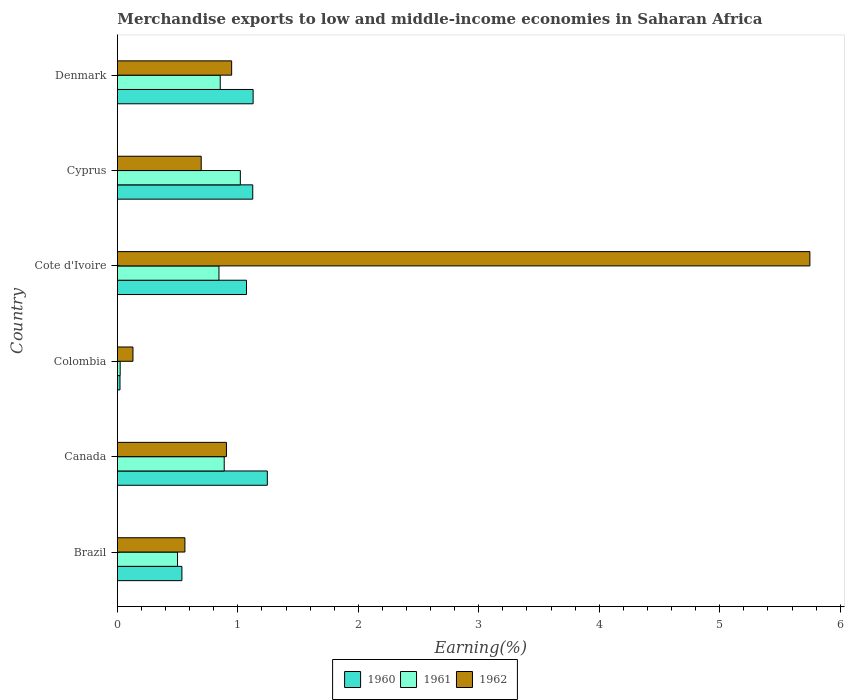How many groups of bars are there?
Your answer should be compact. 6. Are the number of bars on each tick of the Y-axis equal?
Ensure brevity in your answer.  Yes. How many bars are there on the 6th tick from the bottom?
Offer a very short reply. 3. What is the label of the 3rd group of bars from the top?
Your response must be concise. Cote d'Ivoire. In how many cases, is the number of bars for a given country not equal to the number of legend labels?
Make the answer very short. 0. What is the percentage of amount earned from merchandise exports in 1961 in Canada?
Ensure brevity in your answer.  0.89. Across all countries, what is the maximum percentage of amount earned from merchandise exports in 1962?
Your answer should be very brief. 5.75. Across all countries, what is the minimum percentage of amount earned from merchandise exports in 1961?
Your answer should be very brief. 0.02. In which country was the percentage of amount earned from merchandise exports in 1962 maximum?
Ensure brevity in your answer.  Cote d'Ivoire. What is the total percentage of amount earned from merchandise exports in 1962 in the graph?
Offer a terse response. 8.99. What is the difference between the percentage of amount earned from merchandise exports in 1961 in Colombia and that in Cyprus?
Give a very brief answer. -1. What is the difference between the percentage of amount earned from merchandise exports in 1960 in Canada and the percentage of amount earned from merchandise exports in 1961 in Colombia?
Provide a succinct answer. 1.22. What is the average percentage of amount earned from merchandise exports in 1961 per country?
Your answer should be compact. 0.69. What is the difference between the percentage of amount earned from merchandise exports in 1961 and percentage of amount earned from merchandise exports in 1962 in Brazil?
Make the answer very short. -0.06. In how many countries, is the percentage of amount earned from merchandise exports in 1962 greater than 5.2 %?
Your answer should be very brief. 1. What is the ratio of the percentage of amount earned from merchandise exports in 1962 in Brazil to that in Colombia?
Your answer should be compact. 4.34. Is the percentage of amount earned from merchandise exports in 1962 in Colombia less than that in Denmark?
Provide a succinct answer. Yes. What is the difference between the highest and the second highest percentage of amount earned from merchandise exports in 1960?
Offer a very short reply. 0.12. What is the difference between the highest and the lowest percentage of amount earned from merchandise exports in 1960?
Provide a short and direct response. 1.22. Is the sum of the percentage of amount earned from merchandise exports in 1960 in Cote d'Ivoire and Denmark greater than the maximum percentage of amount earned from merchandise exports in 1962 across all countries?
Offer a very short reply. No. What does the 3rd bar from the top in Cyprus represents?
Provide a short and direct response. 1960. Is it the case that in every country, the sum of the percentage of amount earned from merchandise exports in 1962 and percentage of amount earned from merchandise exports in 1960 is greater than the percentage of amount earned from merchandise exports in 1961?
Keep it short and to the point. Yes. Are all the bars in the graph horizontal?
Your answer should be compact. Yes. What is the difference between two consecutive major ticks on the X-axis?
Make the answer very short. 1. Does the graph contain any zero values?
Provide a short and direct response. No. Does the graph contain grids?
Your response must be concise. No. Where does the legend appear in the graph?
Make the answer very short. Bottom center. How many legend labels are there?
Offer a very short reply. 3. What is the title of the graph?
Keep it short and to the point. Merchandise exports to low and middle-income economies in Saharan Africa. Does "1964" appear as one of the legend labels in the graph?
Ensure brevity in your answer.  No. What is the label or title of the X-axis?
Provide a succinct answer. Earning(%). What is the Earning(%) of 1960 in Brazil?
Ensure brevity in your answer.  0.54. What is the Earning(%) of 1961 in Brazil?
Give a very brief answer. 0.5. What is the Earning(%) of 1962 in Brazil?
Offer a terse response. 0.56. What is the Earning(%) in 1960 in Canada?
Provide a short and direct response. 1.24. What is the Earning(%) of 1961 in Canada?
Your response must be concise. 0.89. What is the Earning(%) of 1962 in Canada?
Provide a succinct answer. 0.9. What is the Earning(%) in 1960 in Colombia?
Your response must be concise. 0.02. What is the Earning(%) of 1961 in Colombia?
Offer a terse response. 0.02. What is the Earning(%) of 1962 in Colombia?
Your answer should be very brief. 0.13. What is the Earning(%) in 1960 in Cote d'Ivoire?
Provide a short and direct response. 1.07. What is the Earning(%) in 1961 in Cote d'Ivoire?
Give a very brief answer. 0.84. What is the Earning(%) of 1962 in Cote d'Ivoire?
Make the answer very short. 5.75. What is the Earning(%) of 1960 in Cyprus?
Offer a terse response. 1.12. What is the Earning(%) in 1961 in Cyprus?
Your answer should be very brief. 1.02. What is the Earning(%) in 1962 in Cyprus?
Provide a succinct answer. 0.7. What is the Earning(%) of 1960 in Denmark?
Your answer should be compact. 1.13. What is the Earning(%) of 1961 in Denmark?
Your response must be concise. 0.85. What is the Earning(%) in 1962 in Denmark?
Offer a terse response. 0.95. Across all countries, what is the maximum Earning(%) in 1960?
Give a very brief answer. 1.24. Across all countries, what is the maximum Earning(%) of 1961?
Offer a terse response. 1.02. Across all countries, what is the maximum Earning(%) of 1962?
Your answer should be compact. 5.75. Across all countries, what is the minimum Earning(%) in 1960?
Your answer should be very brief. 0.02. Across all countries, what is the minimum Earning(%) in 1961?
Offer a very short reply. 0.02. Across all countries, what is the minimum Earning(%) in 1962?
Your answer should be very brief. 0.13. What is the total Earning(%) in 1960 in the graph?
Make the answer very short. 5.12. What is the total Earning(%) in 1961 in the graph?
Your answer should be very brief. 4.13. What is the total Earning(%) in 1962 in the graph?
Your answer should be very brief. 8.99. What is the difference between the Earning(%) in 1960 in Brazil and that in Canada?
Offer a terse response. -0.71. What is the difference between the Earning(%) of 1961 in Brazil and that in Canada?
Give a very brief answer. -0.39. What is the difference between the Earning(%) in 1962 in Brazil and that in Canada?
Offer a terse response. -0.34. What is the difference between the Earning(%) in 1960 in Brazil and that in Colombia?
Offer a terse response. 0.51. What is the difference between the Earning(%) in 1961 in Brazil and that in Colombia?
Your answer should be compact. 0.48. What is the difference between the Earning(%) in 1962 in Brazil and that in Colombia?
Offer a very short reply. 0.43. What is the difference between the Earning(%) in 1960 in Brazil and that in Cote d'Ivoire?
Ensure brevity in your answer.  -0.54. What is the difference between the Earning(%) in 1961 in Brazil and that in Cote d'Ivoire?
Give a very brief answer. -0.34. What is the difference between the Earning(%) in 1962 in Brazil and that in Cote d'Ivoire?
Your answer should be compact. -5.19. What is the difference between the Earning(%) in 1960 in Brazil and that in Cyprus?
Give a very brief answer. -0.59. What is the difference between the Earning(%) of 1961 in Brazil and that in Cyprus?
Make the answer very short. -0.52. What is the difference between the Earning(%) in 1962 in Brazil and that in Cyprus?
Offer a very short reply. -0.14. What is the difference between the Earning(%) of 1960 in Brazil and that in Denmark?
Keep it short and to the point. -0.59. What is the difference between the Earning(%) in 1961 in Brazil and that in Denmark?
Ensure brevity in your answer.  -0.35. What is the difference between the Earning(%) of 1962 in Brazil and that in Denmark?
Offer a terse response. -0.39. What is the difference between the Earning(%) in 1960 in Canada and that in Colombia?
Your answer should be very brief. 1.22. What is the difference between the Earning(%) in 1961 in Canada and that in Colombia?
Provide a short and direct response. 0.86. What is the difference between the Earning(%) of 1962 in Canada and that in Colombia?
Offer a very short reply. 0.78. What is the difference between the Earning(%) of 1960 in Canada and that in Cote d'Ivoire?
Offer a very short reply. 0.17. What is the difference between the Earning(%) of 1961 in Canada and that in Cote d'Ivoire?
Keep it short and to the point. 0.04. What is the difference between the Earning(%) in 1962 in Canada and that in Cote d'Ivoire?
Provide a succinct answer. -4.84. What is the difference between the Earning(%) of 1960 in Canada and that in Cyprus?
Make the answer very short. 0.12. What is the difference between the Earning(%) in 1961 in Canada and that in Cyprus?
Offer a terse response. -0.13. What is the difference between the Earning(%) in 1962 in Canada and that in Cyprus?
Provide a succinct answer. 0.21. What is the difference between the Earning(%) of 1960 in Canada and that in Denmark?
Provide a short and direct response. 0.12. What is the difference between the Earning(%) of 1961 in Canada and that in Denmark?
Offer a terse response. 0.03. What is the difference between the Earning(%) in 1962 in Canada and that in Denmark?
Offer a very short reply. -0.04. What is the difference between the Earning(%) in 1960 in Colombia and that in Cote d'Ivoire?
Your answer should be very brief. -1.05. What is the difference between the Earning(%) in 1961 in Colombia and that in Cote d'Ivoire?
Offer a terse response. -0.82. What is the difference between the Earning(%) in 1962 in Colombia and that in Cote d'Ivoire?
Keep it short and to the point. -5.62. What is the difference between the Earning(%) in 1960 in Colombia and that in Cyprus?
Provide a succinct answer. -1.1. What is the difference between the Earning(%) in 1961 in Colombia and that in Cyprus?
Keep it short and to the point. -1. What is the difference between the Earning(%) in 1962 in Colombia and that in Cyprus?
Give a very brief answer. -0.57. What is the difference between the Earning(%) of 1960 in Colombia and that in Denmark?
Keep it short and to the point. -1.11. What is the difference between the Earning(%) in 1961 in Colombia and that in Denmark?
Offer a very short reply. -0.83. What is the difference between the Earning(%) of 1962 in Colombia and that in Denmark?
Give a very brief answer. -0.82. What is the difference between the Earning(%) in 1960 in Cote d'Ivoire and that in Cyprus?
Offer a terse response. -0.05. What is the difference between the Earning(%) in 1961 in Cote d'Ivoire and that in Cyprus?
Keep it short and to the point. -0.18. What is the difference between the Earning(%) of 1962 in Cote d'Ivoire and that in Cyprus?
Ensure brevity in your answer.  5.05. What is the difference between the Earning(%) in 1960 in Cote d'Ivoire and that in Denmark?
Provide a succinct answer. -0.06. What is the difference between the Earning(%) of 1961 in Cote d'Ivoire and that in Denmark?
Your answer should be compact. -0.01. What is the difference between the Earning(%) in 1962 in Cote d'Ivoire and that in Denmark?
Your answer should be very brief. 4.8. What is the difference between the Earning(%) in 1960 in Cyprus and that in Denmark?
Provide a succinct answer. -0. What is the difference between the Earning(%) of 1961 in Cyprus and that in Denmark?
Offer a very short reply. 0.17. What is the difference between the Earning(%) of 1962 in Cyprus and that in Denmark?
Offer a terse response. -0.25. What is the difference between the Earning(%) of 1960 in Brazil and the Earning(%) of 1961 in Canada?
Your answer should be compact. -0.35. What is the difference between the Earning(%) of 1960 in Brazil and the Earning(%) of 1962 in Canada?
Your response must be concise. -0.37. What is the difference between the Earning(%) of 1961 in Brazil and the Earning(%) of 1962 in Canada?
Give a very brief answer. -0.41. What is the difference between the Earning(%) in 1960 in Brazil and the Earning(%) in 1961 in Colombia?
Provide a short and direct response. 0.51. What is the difference between the Earning(%) of 1960 in Brazil and the Earning(%) of 1962 in Colombia?
Offer a very short reply. 0.41. What is the difference between the Earning(%) in 1961 in Brazil and the Earning(%) in 1962 in Colombia?
Your answer should be very brief. 0.37. What is the difference between the Earning(%) of 1960 in Brazil and the Earning(%) of 1961 in Cote d'Ivoire?
Ensure brevity in your answer.  -0.31. What is the difference between the Earning(%) of 1960 in Brazil and the Earning(%) of 1962 in Cote d'Ivoire?
Ensure brevity in your answer.  -5.21. What is the difference between the Earning(%) in 1961 in Brazil and the Earning(%) in 1962 in Cote d'Ivoire?
Ensure brevity in your answer.  -5.25. What is the difference between the Earning(%) in 1960 in Brazil and the Earning(%) in 1961 in Cyprus?
Offer a very short reply. -0.48. What is the difference between the Earning(%) of 1960 in Brazil and the Earning(%) of 1962 in Cyprus?
Provide a succinct answer. -0.16. What is the difference between the Earning(%) in 1961 in Brazil and the Earning(%) in 1962 in Cyprus?
Give a very brief answer. -0.2. What is the difference between the Earning(%) of 1960 in Brazil and the Earning(%) of 1961 in Denmark?
Offer a very short reply. -0.32. What is the difference between the Earning(%) of 1960 in Brazil and the Earning(%) of 1962 in Denmark?
Offer a terse response. -0.41. What is the difference between the Earning(%) in 1961 in Brazil and the Earning(%) in 1962 in Denmark?
Provide a short and direct response. -0.45. What is the difference between the Earning(%) of 1960 in Canada and the Earning(%) of 1961 in Colombia?
Make the answer very short. 1.22. What is the difference between the Earning(%) in 1960 in Canada and the Earning(%) in 1962 in Colombia?
Provide a short and direct response. 1.12. What is the difference between the Earning(%) in 1961 in Canada and the Earning(%) in 1962 in Colombia?
Make the answer very short. 0.76. What is the difference between the Earning(%) of 1960 in Canada and the Earning(%) of 1961 in Cote d'Ivoire?
Your answer should be compact. 0.4. What is the difference between the Earning(%) of 1960 in Canada and the Earning(%) of 1962 in Cote d'Ivoire?
Your answer should be very brief. -4.5. What is the difference between the Earning(%) in 1961 in Canada and the Earning(%) in 1962 in Cote d'Ivoire?
Your answer should be very brief. -4.86. What is the difference between the Earning(%) of 1960 in Canada and the Earning(%) of 1961 in Cyprus?
Provide a succinct answer. 0.22. What is the difference between the Earning(%) of 1960 in Canada and the Earning(%) of 1962 in Cyprus?
Your answer should be compact. 0.55. What is the difference between the Earning(%) in 1961 in Canada and the Earning(%) in 1962 in Cyprus?
Your answer should be very brief. 0.19. What is the difference between the Earning(%) in 1960 in Canada and the Earning(%) in 1961 in Denmark?
Make the answer very short. 0.39. What is the difference between the Earning(%) of 1960 in Canada and the Earning(%) of 1962 in Denmark?
Offer a very short reply. 0.3. What is the difference between the Earning(%) in 1961 in Canada and the Earning(%) in 1962 in Denmark?
Keep it short and to the point. -0.06. What is the difference between the Earning(%) of 1960 in Colombia and the Earning(%) of 1961 in Cote d'Ivoire?
Offer a terse response. -0.82. What is the difference between the Earning(%) of 1960 in Colombia and the Earning(%) of 1962 in Cote d'Ivoire?
Keep it short and to the point. -5.73. What is the difference between the Earning(%) in 1961 in Colombia and the Earning(%) in 1962 in Cote d'Ivoire?
Ensure brevity in your answer.  -5.73. What is the difference between the Earning(%) in 1960 in Colombia and the Earning(%) in 1961 in Cyprus?
Make the answer very short. -1. What is the difference between the Earning(%) in 1960 in Colombia and the Earning(%) in 1962 in Cyprus?
Keep it short and to the point. -0.67. What is the difference between the Earning(%) of 1961 in Colombia and the Earning(%) of 1962 in Cyprus?
Provide a short and direct response. -0.67. What is the difference between the Earning(%) in 1960 in Colombia and the Earning(%) in 1961 in Denmark?
Your response must be concise. -0.83. What is the difference between the Earning(%) in 1960 in Colombia and the Earning(%) in 1962 in Denmark?
Give a very brief answer. -0.93. What is the difference between the Earning(%) of 1961 in Colombia and the Earning(%) of 1962 in Denmark?
Ensure brevity in your answer.  -0.93. What is the difference between the Earning(%) of 1960 in Cote d'Ivoire and the Earning(%) of 1961 in Cyprus?
Your answer should be compact. 0.05. What is the difference between the Earning(%) of 1960 in Cote d'Ivoire and the Earning(%) of 1962 in Cyprus?
Offer a terse response. 0.38. What is the difference between the Earning(%) in 1961 in Cote d'Ivoire and the Earning(%) in 1962 in Cyprus?
Give a very brief answer. 0.15. What is the difference between the Earning(%) in 1960 in Cote d'Ivoire and the Earning(%) in 1961 in Denmark?
Provide a short and direct response. 0.22. What is the difference between the Earning(%) in 1960 in Cote d'Ivoire and the Earning(%) in 1962 in Denmark?
Your answer should be very brief. 0.12. What is the difference between the Earning(%) of 1961 in Cote d'Ivoire and the Earning(%) of 1962 in Denmark?
Provide a succinct answer. -0.11. What is the difference between the Earning(%) of 1960 in Cyprus and the Earning(%) of 1961 in Denmark?
Your answer should be very brief. 0.27. What is the difference between the Earning(%) in 1960 in Cyprus and the Earning(%) in 1962 in Denmark?
Offer a very short reply. 0.18. What is the difference between the Earning(%) in 1961 in Cyprus and the Earning(%) in 1962 in Denmark?
Make the answer very short. 0.07. What is the average Earning(%) in 1960 per country?
Give a very brief answer. 0.85. What is the average Earning(%) in 1961 per country?
Ensure brevity in your answer.  0.69. What is the average Earning(%) in 1962 per country?
Make the answer very short. 1.5. What is the difference between the Earning(%) of 1960 and Earning(%) of 1961 in Brazil?
Your answer should be compact. 0.04. What is the difference between the Earning(%) in 1960 and Earning(%) in 1962 in Brazil?
Ensure brevity in your answer.  -0.02. What is the difference between the Earning(%) of 1961 and Earning(%) of 1962 in Brazil?
Offer a very short reply. -0.06. What is the difference between the Earning(%) of 1960 and Earning(%) of 1961 in Canada?
Ensure brevity in your answer.  0.36. What is the difference between the Earning(%) of 1960 and Earning(%) of 1962 in Canada?
Your response must be concise. 0.34. What is the difference between the Earning(%) in 1961 and Earning(%) in 1962 in Canada?
Provide a short and direct response. -0.02. What is the difference between the Earning(%) of 1960 and Earning(%) of 1961 in Colombia?
Provide a succinct answer. -0. What is the difference between the Earning(%) of 1960 and Earning(%) of 1962 in Colombia?
Keep it short and to the point. -0.11. What is the difference between the Earning(%) in 1961 and Earning(%) in 1962 in Colombia?
Make the answer very short. -0.11. What is the difference between the Earning(%) in 1960 and Earning(%) in 1961 in Cote d'Ivoire?
Give a very brief answer. 0.23. What is the difference between the Earning(%) in 1960 and Earning(%) in 1962 in Cote d'Ivoire?
Offer a very short reply. -4.68. What is the difference between the Earning(%) of 1961 and Earning(%) of 1962 in Cote d'Ivoire?
Ensure brevity in your answer.  -4.91. What is the difference between the Earning(%) of 1960 and Earning(%) of 1961 in Cyprus?
Make the answer very short. 0.1. What is the difference between the Earning(%) in 1960 and Earning(%) in 1962 in Cyprus?
Your answer should be compact. 0.43. What is the difference between the Earning(%) in 1961 and Earning(%) in 1962 in Cyprus?
Ensure brevity in your answer.  0.32. What is the difference between the Earning(%) in 1960 and Earning(%) in 1961 in Denmark?
Ensure brevity in your answer.  0.27. What is the difference between the Earning(%) in 1960 and Earning(%) in 1962 in Denmark?
Keep it short and to the point. 0.18. What is the difference between the Earning(%) in 1961 and Earning(%) in 1962 in Denmark?
Make the answer very short. -0.09. What is the ratio of the Earning(%) in 1960 in Brazil to that in Canada?
Your answer should be very brief. 0.43. What is the ratio of the Earning(%) in 1961 in Brazil to that in Canada?
Provide a succinct answer. 0.56. What is the ratio of the Earning(%) in 1962 in Brazil to that in Canada?
Your response must be concise. 0.62. What is the ratio of the Earning(%) in 1960 in Brazil to that in Colombia?
Provide a succinct answer. 24.92. What is the ratio of the Earning(%) of 1961 in Brazil to that in Colombia?
Offer a very short reply. 21.72. What is the ratio of the Earning(%) of 1962 in Brazil to that in Colombia?
Provide a short and direct response. 4.34. What is the ratio of the Earning(%) in 1960 in Brazil to that in Cote d'Ivoire?
Offer a terse response. 0.5. What is the ratio of the Earning(%) in 1961 in Brazil to that in Cote d'Ivoire?
Make the answer very short. 0.59. What is the ratio of the Earning(%) in 1962 in Brazil to that in Cote d'Ivoire?
Make the answer very short. 0.1. What is the ratio of the Earning(%) of 1960 in Brazil to that in Cyprus?
Give a very brief answer. 0.48. What is the ratio of the Earning(%) of 1961 in Brazil to that in Cyprus?
Your response must be concise. 0.49. What is the ratio of the Earning(%) in 1962 in Brazil to that in Cyprus?
Ensure brevity in your answer.  0.81. What is the ratio of the Earning(%) of 1960 in Brazil to that in Denmark?
Offer a very short reply. 0.48. What is the ratio of the Earning(%) in 1961 in Brazil to that in Denmark?
Give a very brief answer. 0.58. What is the ratio of the Earning(%) in 1962 in Brazil to that in Denmark?
Provide a short and direct response. 0.59. What is the ratio of the Earning(%) of 1960 in Canada to that in Colombia?
Keep it short and to the point. 57.92. What is the ratio of the Earning(%) of 1961 in Canada to that in Colombia?
Provide a succinct answer. 38.58. What is the ratio of the Earning(%) in 1962 in Canada to that in Colombia?
Provide a succinct answer. 7.01. What is the ratio of the Earning(%) in 1960 in Canada to that in Cote d'Ivoire?
Ensure brevity in your answer.  1.16. What is the ratio of the Earning(%) in 1961 in Canada to that in Cote d'Ivoire?
Provide a succinct answer. 1.05. What is the ratio of the Earning(%) in 1962 in Canada to that in Cote d'Ivoire?
Provide a short and direct response. 0.16. What is the ratio of the Earning(%) of 1960 in Canada to that in Cyprus?
Keep it short and to the point. 1.11. What is the ratio of the Earning(%) of 1961 in Canada to that in Cyprus?
Your answer should be very brief. 0.87. What is the ratio of the Earning(%) of 1962 in Canada to that in Cyprus?
Offer a very short reply. 1.3. What is the ratio of the Earning(%) in 1960 in Canada to that in Denmark?
Your answer should be compact. 1.1. What is the ratio of the Earning(%) of 1961 in Canada to that in Denmark?
Ensure brevity in your answer.  1.04. What is the ratio of the Earning(%) of 1962 in Canada to that in Denmark?
Your answer should be very brief. 0.95. What is the ratio of the Earning(%) in 1960 in Colombia to that in Cote d'Ivoire?
Your answer should be compact. 0.02. What is the ratio of the Earning(%) of 1961 in Colombia to that in Cote d'Ivoire?
Your answer should be very brief. 0.03. What is the ratio of the Earning(%) in 1962 in Colombia to that in Cote d'Ivoire?
Your answer should be very brief. 0.02. What is the ratio of the Earning(%) in 1960 in Colombia to that in Cyprus?
Provide a succinct answer. 0.02. What is the ratio of the Earning(%) of 1961 in Colombia to that in Cyprus?
Make the answer very short. 0.02. What is the ratio of the Earning(%) in 1962 in Colombia to that in Cyprus?
Offer a terse response. 0.19. What is the ratio of the Earning(%) in 1960 in Colombia to that in Denmark?
Make the answer very short. 0.02. What is the ratio of the Earning(%) of 1961 in Colombia to that in Denmark?
Provide a short and direct response. 0.03. What is the ratio of the Earning(%) in 1962 in Colombia to that in Denmark?
Keep it short and to the point. 0.14. What is the ratio of the Earning(%) of 1960 in Cote d'Ivoire to that in Cyprus?
Give a very brief answer. 0.95. What is the ratio of the Earning(%) in 1961 in Cote d'Ivoire to that in Cyprus?
Ensure brevity in your answer.  0.83. What is the ratio of the Earning(%) in 1962 in Cote d'Ivoire to that in Cyprus?
Your answer should be compact. 8.26. What is the ratio of the Earning(%) in 1960 in Cote d'Ivoire to that in Denmark?
Provide a succinct answer. 0.95. What is the ratio of the Earning(%) of 1961 in Cote d'Ivoire to that in Denmark?
Offer a very short reply. 0.99. What is the ratio of the Earning(%) in 1962 in Cote d'Ivoire to that in Denmark?
Your answer should be compact. 6.06. What is the ratio of the Earning(%) of 1961 in Cyprus to that in Denmark?
Provide a short and direct response. 1.2. What is the ratio of the Earning(%) in 1962 in Cyprus to that in Denmark?
Ensure brevity in your answer.  0.73. What is the difference between the highest and the second highest Earning(%) in 1960?
Ensure brevity in your answer.  0.12. What is the difference between the highest and the second highest Earning(%) of 1961?
Ensure brevity in your answer.  0.13. What is the difference between the highest and the second highest Earning(%) in 1962?
Offer a terse response. 4.8. What is the difference between the highest and the lowest Earning(%) of 1960?
Make the answer very short. 1.22. What is the difference between the highest and the lowest Earning(%) of 1962?
Make the answer very short. 5.62. 